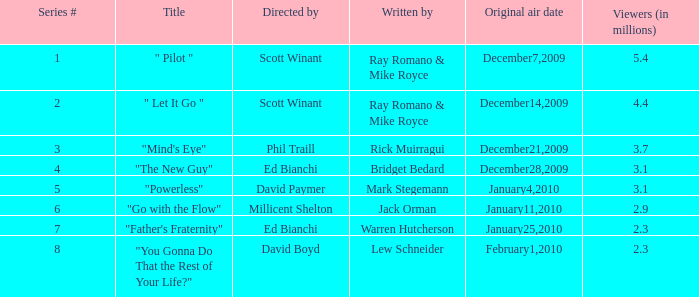On which date was the initial airing of "powerless"? January4,2010. 